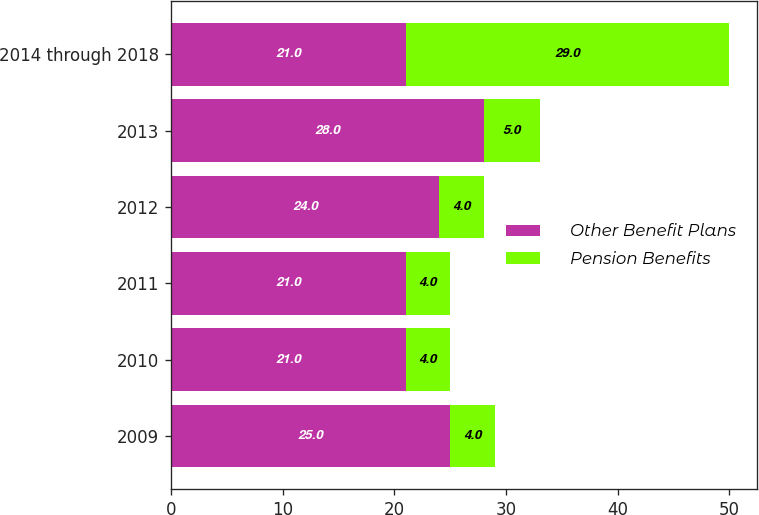Convert chart to OTSL. <chart><loc_0><loc_0><loc_500><loc_500><stacked_bar_chart><ecel><fcel>2009<fcel>2010<fcel>2011<fcel>2012<fcel>2013<fcel>2014 through 2018<nl><fcel>Other Benefit Plans<fcel>25<fcel>21<fcel>21<fcel>24<fcel>28<fcel>21<nl><fcel>Pension Benefits<fcel>4<fcel>4<fcel>4<fcel>4<fcel>5<fcel>29<nl></chart> 